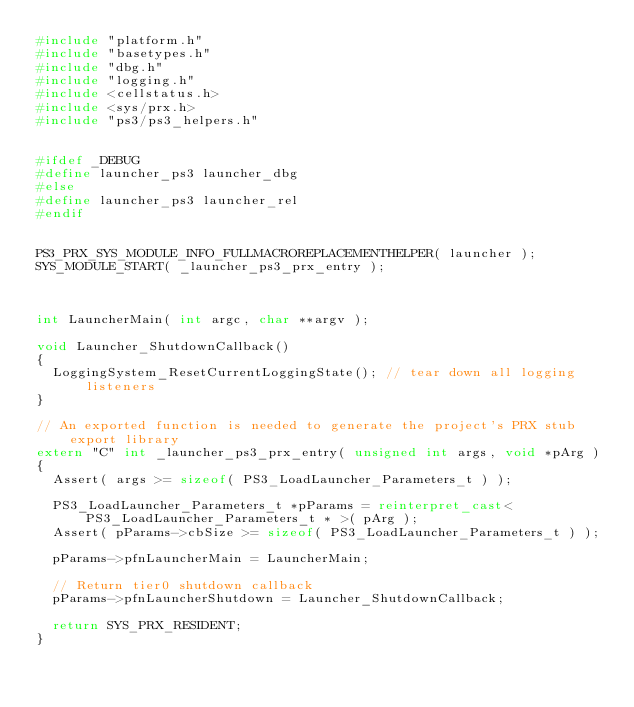Convert code to text. <code><loc_0><loc_0><loc_500><loc_500><_C++_>#include "platform.h"
#include "basetypes.h"
#include "dbg.h"
#include "logging.h"
#include <cellstatus.h>
#include <sys/prx.h>
#include "ps3/ps3_helpers.h"


#ifdef _DEBUG
#define launcher_ps3 launcher_dbg
#else
#define launcher_ps3 launcher_rel
#endif


PS3_PRX_SYS_MODULE_INFO_FULLMACROREPLACEMENTHELPER( launcher );
SYS_MODULE_START( _launcher_ps3_prx_entry );



int LauncherMain( int argc, char **argv );

void Launcher_ShutdownCallback()
{
	LoggingSystem_ResetCurrentLoggingState();	// tear down all logging listeners
}

// An exported function is needed to generate the project's PRX stub export library
extern "C" int _launcher_ps3_prx_entry( unsigned int args, void *pArg )
{
	Assert( args >= sizeof( PS3_LoadLauncher_Parameters_t ) );
	
	PS3_LoadLauncher_Parameters_t *pParams = reinterpret_cast< PS3_LoadLauncher_Parameters_t * >( pArg );
	Assert( pParams->cbSize >= sizeof( PS3_LoadLauncher_Parameters_t ) );
	
	pParams->pfnLauncherMain = LauncherMain;

	// Return tier0 shutdown callback
	pParams->pfnLauncherShutdown = Launcher_ShutdownCallback;

	return SYS_PRX_RESIDENT;
}

</code> 